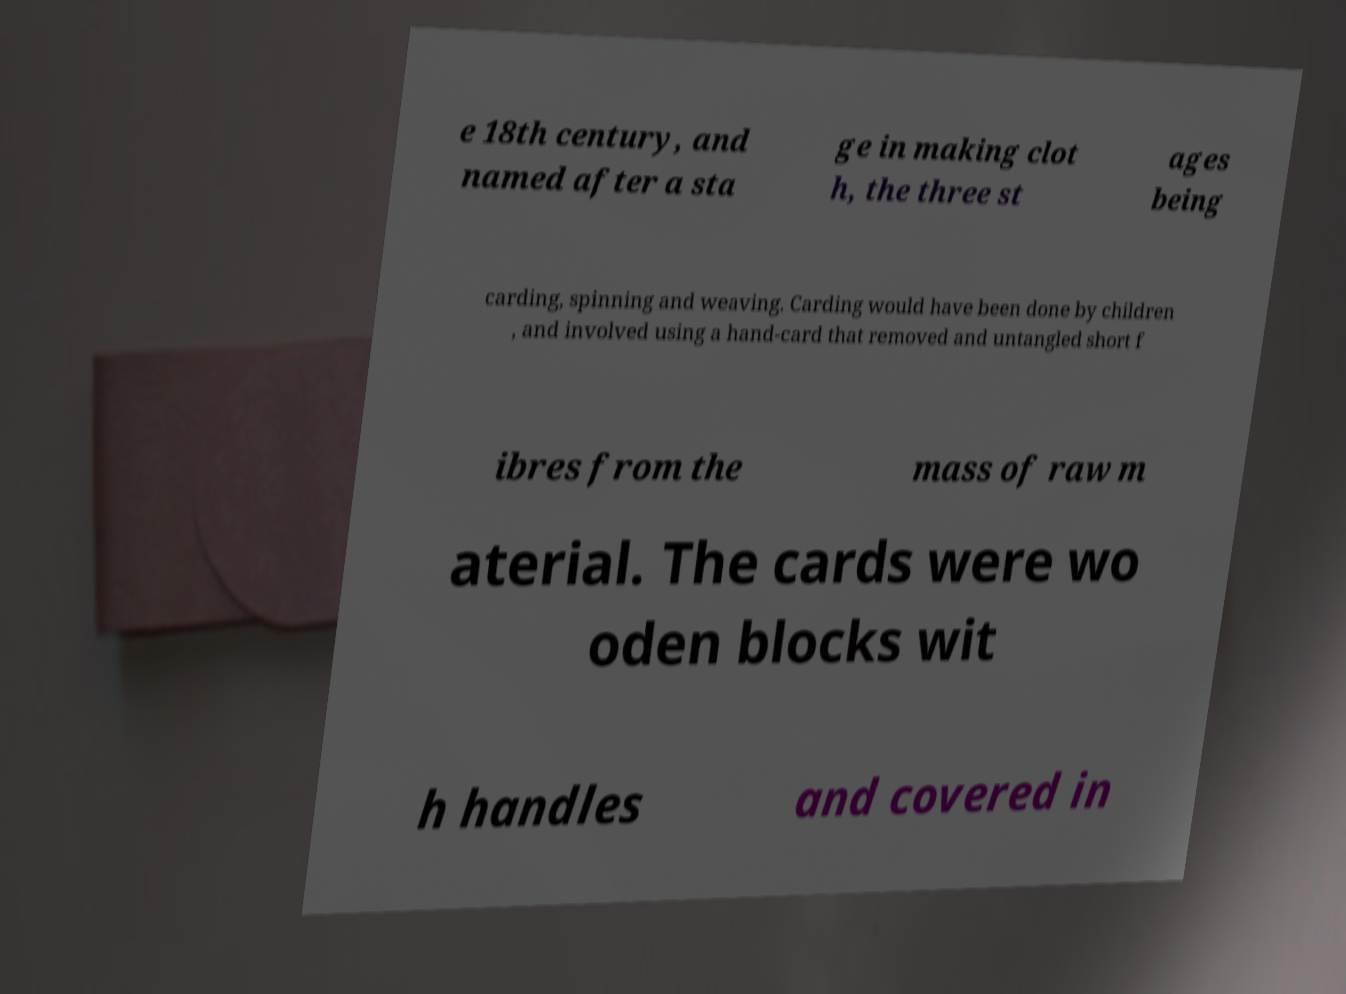I need the written content from this picture converted into text. Can you do that? e 18th century, and named after a sta ge in making clot h, the three st ages being carding, spinning and weaving. Carding would have been done by children , and involved using a hand-card that removed and untangled short f ibres from the mass of raw m aterial. The cards were wo oden blocks wit h handles and covered in 